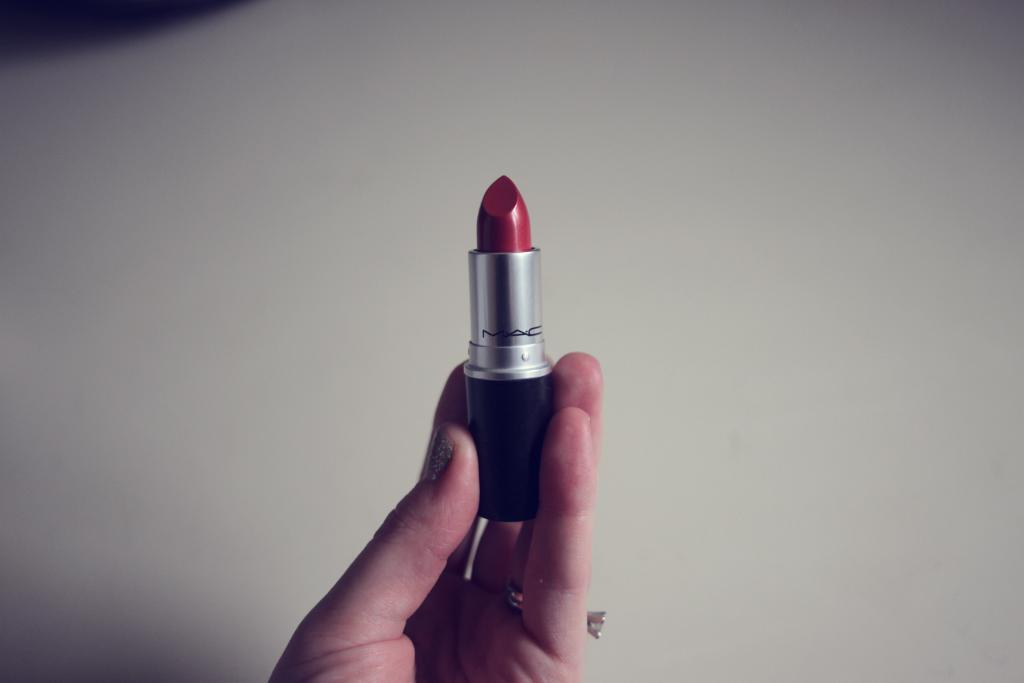What is the main subject of the image? There is a person in the image. What is the person holding in the image? The person is holding a lipstick. What color is the lipstick? The lipstick is red in color. What is the color of the background in the image? The background of the image is white. What type of mint can be seen growing in the image? There is no mint present in the image; it features a person holding a red lipstick against a white background. Can you tell me how many spades are visible in the image? There are no spades present in the image; it only features a person holding a red lipstick against a white background. 